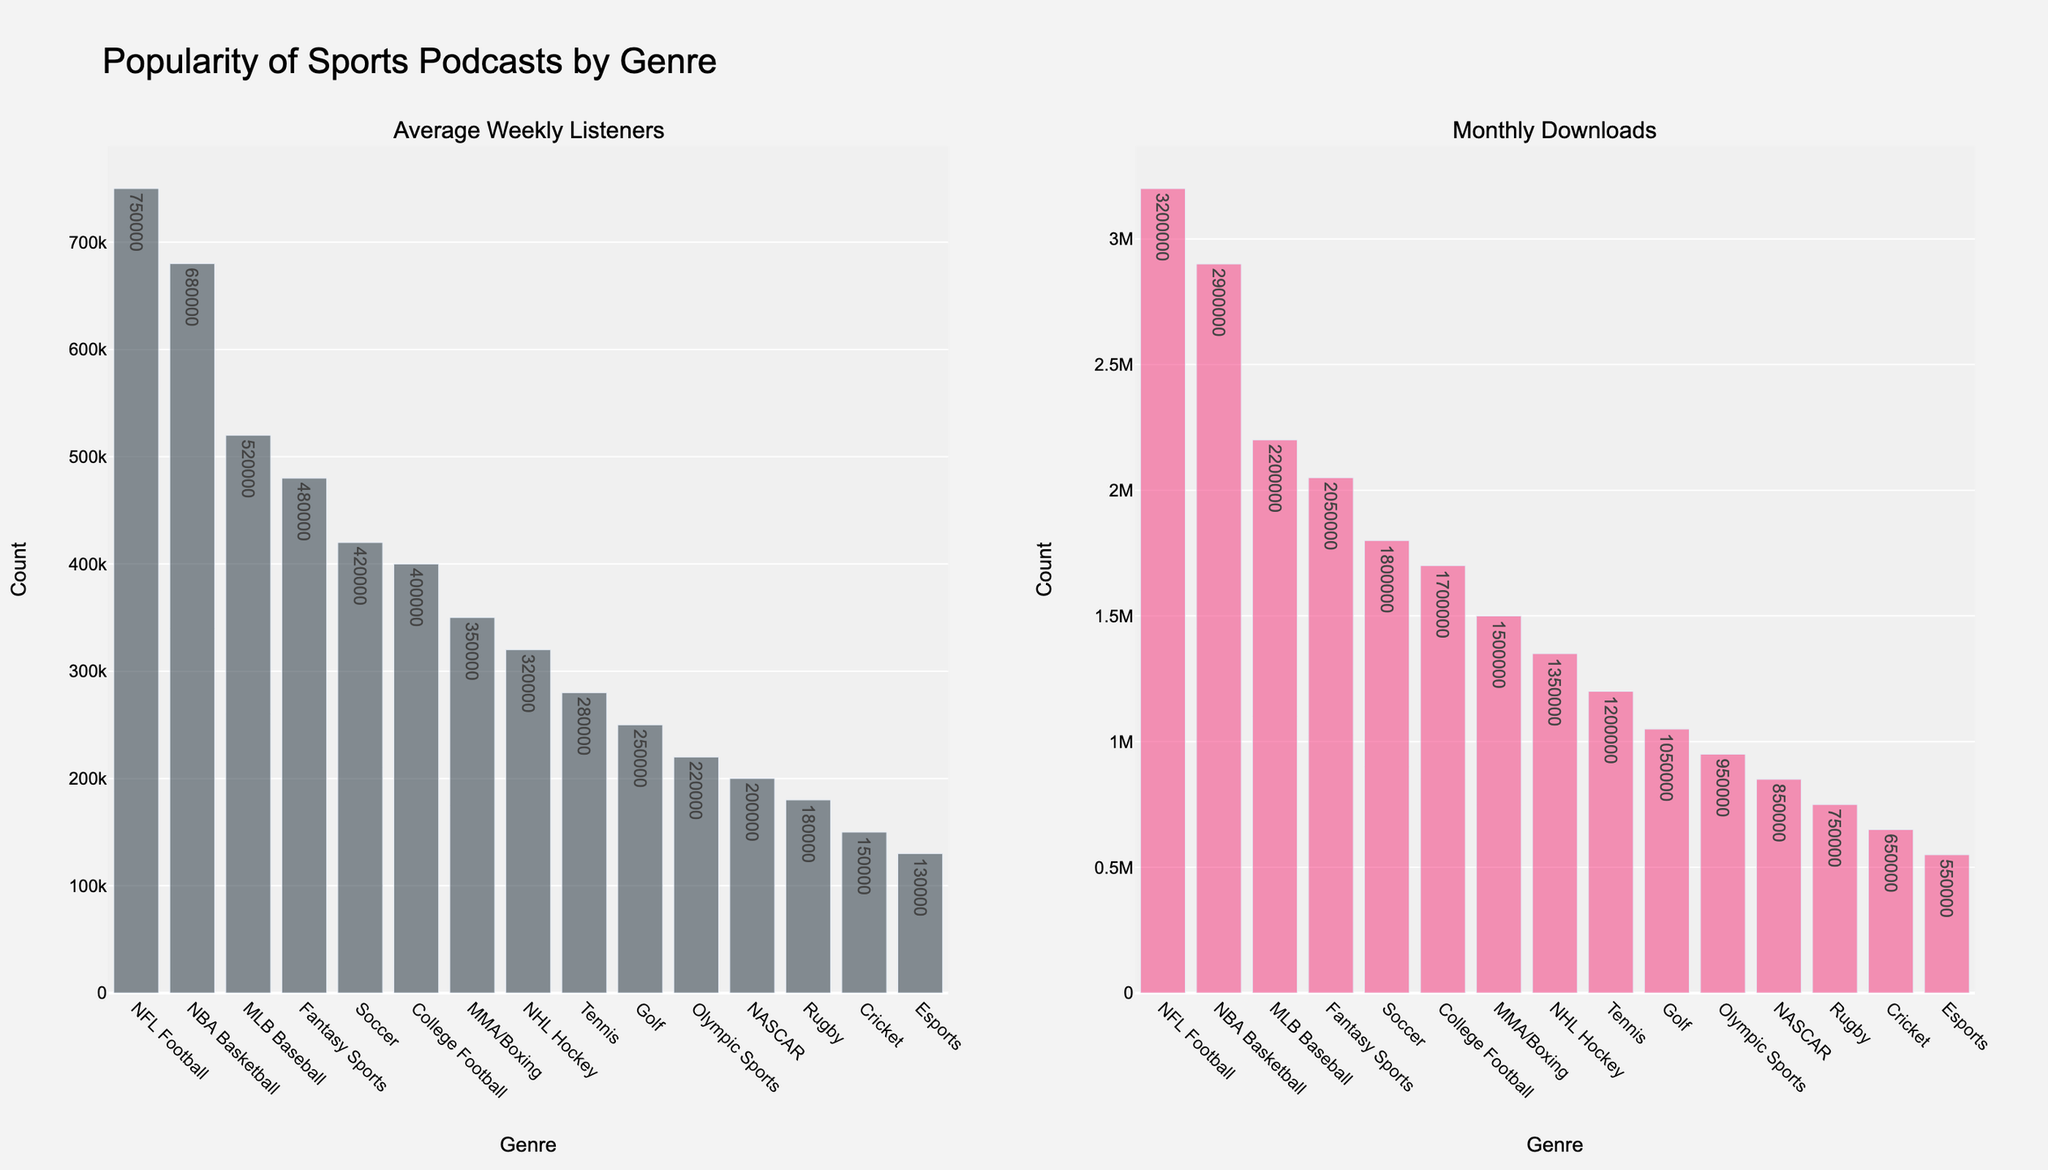Which genre has the highest average weekly listeners? The bar chart for average weekly listeners shows the highest bar for NFL Football.
Answer: NFL Football Which genre has more average weekly listeners: Soccer or College Football? By comparing the heights of the bars in the average weekly listeners plot, Soccer has a taller bar than College Football.
Answer: Soccer What are the three genres with the lowest monthly downloads? By looking at the monthly downloads bars, the shortest three are for Rugby, Cricket, and Esports.
Answer: Rugby, Cricket, Esports How many more monthly downloads does NBA Basketball have compared to MLB Baseball? NBA Basketball has 2,900,000 downloads, and MLB Baseball has 2,200,000. The difference is 2,900,000 - 2,200,000, which equals 700,000.
Answer: 700,000 Which genre has a higher rate of conversion from average weekly listeners to monthly downloads: Tennis or NASCAR? Compute the ratio of monthly downloads to average weekly listeners for both genres. Tennis: 1,200,000 / 280,000 ≈ 4.29. NASCAR: 850,000 / 200,000 = 4.25. Tennis has a higher conversion rate.
Answer: Tennis Is the number of monthly downloads for MMA/Boxing greater than the sum of average weekly listeners for Tennis and Golf combined? Monthly downloads for MMA/Boxing are 1,500,000. The sum of weekly listeners for Tennis (280,000) and Golf (250,000) is 530,000. 1,500,000 is greater than 530,000.
Answer: Yes Which genre has a greater difference between average weekly listeners and monthly downloads: Fantasy Sports or Soccer? Calculate the difference for each: Fantasy Sports: 2,050,000 - 480,000 = 1,570,000. Soccer: 1,800,000 - 420,000 = 1,380,000. Fantasy Sports has a greater difference.
Answer: Fantasy Sports What is the average number of average weekly listeners among the top four genres? The top four genres by average weekly listeners are NFL Football (750,000), NBA Basketball (680,000), MLB Baseball (520,000), and Fantasy Sports (480,000). Their mean is (750,000 + 680,000 + 520,000 + 480,000) / 4 = 607,500.
Answer: 607,500 Between Rugby and Cricket, which has fewer average weekly listeners, and by how much? Rugby has 180,000 listeners, and Cricket has 150,000. The difference is 180,000 - 150,000 = 30,000.
Answer: Cricket, 30,000 Which genre has the smallest difference between average weekly listeners and monthly downloads, and what is this difference? Calculate the difference for each genre and find the smallest: Esports: 550,000 - 130,000 = 420,000. This is the smallest difference among the genres given.
Answer: Esports, 420,000 